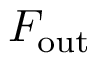Convert formula to latex. <formula><loc_0><loc_0><loc_500><loc_500>F _ { o u t }</formula> 